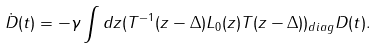Convert formula to latex. <formula><loc_0><loc_0><loc_500><loc_500>\dot { D } ( t ) = - \gamma \int d z ( T ^ { - 1 } ( z - \Delta ) L _ { 0 } ( z ) T ( z - \Delta ) ) _ { d i a g } D ( t ) .</formula> 